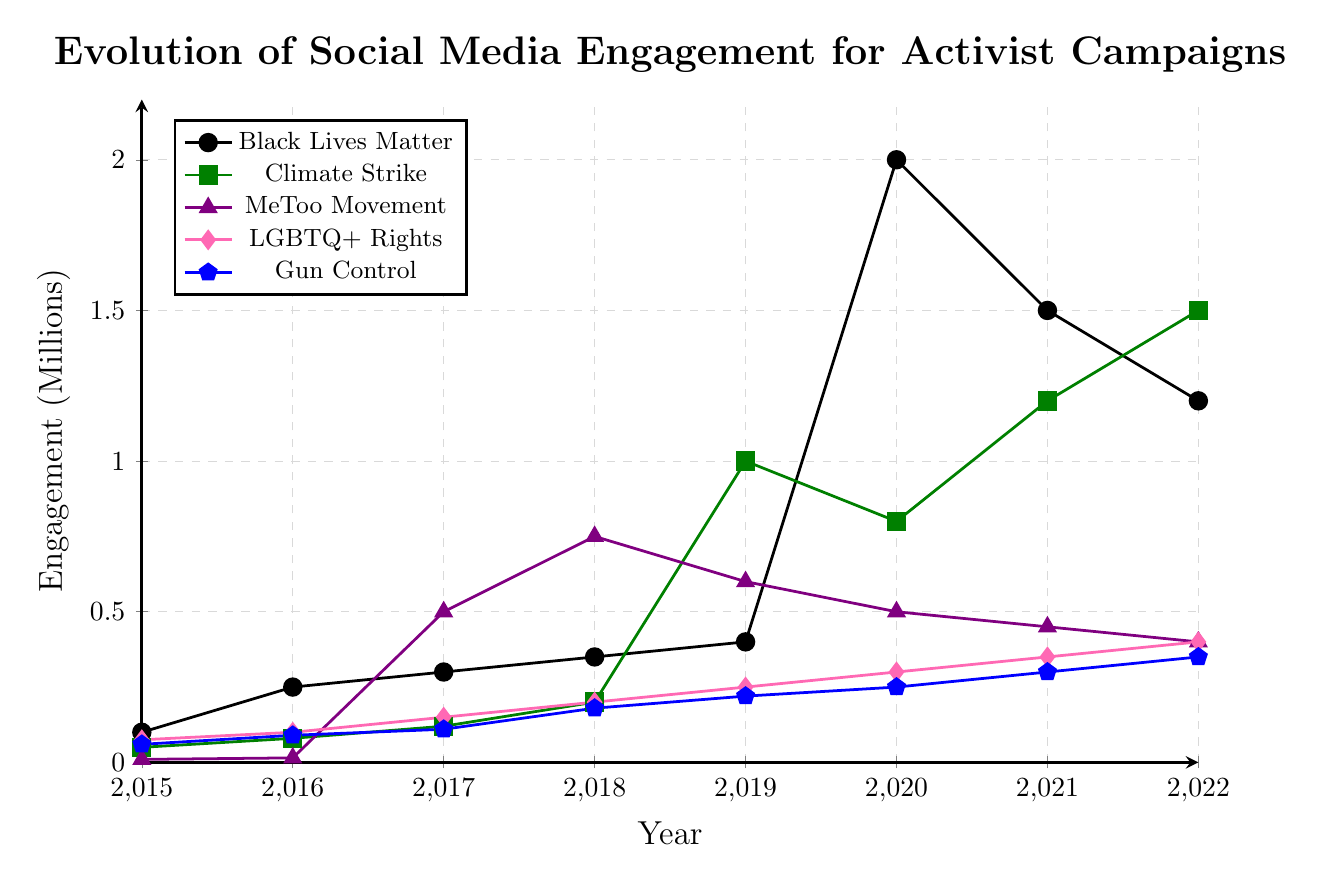What was the highest engagement for the Black Lives Matter campaign, and in what year did it occur? The highest engagement for the Black Lives Matter campaign can be identified by looking at the peak value on the chart. This value occurs in the year 2020.
Answer: 2020, 2 million Which campaign had the lowest engagement in 2015 and what was the value? To find the campaign with the lowest engagement in 2015, look at the starting values for all campaigns in 2015. The MeToo Movement had the lowest engagement at 0.01 million (10,000).
Answer: MeToo Movement, 0.01 million By how much did the engagement for Climate Strike increase from 2017 to 2018? Check the values for Climate Strike in the years 2017 and 2018. In 2017, it was 0.12 million, and in 2018, it was 0.2 million. The increase is 0.2 - 0.12 = 0.08 million.
Answer: 0.08 million Compare the engagement trends of the Gun Control campaign and the LGBTQ+ Rights campaign in 2022. Which had higher engagement and by how much? To compare, check the engagement levels for both campaigns in 2022. Gun Control had 0.35 million, and LGBTQ+ Rights had 0.4 million. LGBTQ+ Rights had higher engagement by 0.4 - 0.35 = 0.05 million.
Answer: LGBTQ+ Rights, 0.05 million What is the average engagement for the MeToo Movement campaign from 2017 to 2022? To find the average engagement, sum the values of the MeToo Movement from 2017 to 2022 and divide by the number of years. (0.5 + 0.75 + 0.6 + 0.5 + 0.45 + 0.4) / 6 = 3.2 / 6 = 0.533 million.
Answer: 0.533 million In 2019, which campaign witnessed the highest engagement, and what was its engagement level? Check the engagement values for all campaigns in the year 2019. Climate Strike had the highest engagement at 1 million.
Answer: Climate Strike, 1 million Which year shows a drop in engagement for the Gun Control campaign compared to the previous year, and what is the difference? Look for the year-over-year engagement values of the Gun Control campaign. From 2018 to 2019, there is a slight drop, but it's an increase when compared to previous years. There's no actual drop.
Answer: None How many campaigns had an engagement of at least 1 million in any given year? Look through each year's data to find campaigns that reached at least 1 million engagement. Black Lives Matter reached 1 million in 2020 and 2021. Climate Strike reached 1 million in 2019, 2021, and 2022. So, two campaigns meet this criterion.
Answer: Two campaigns If you sum the highest engagement figures for all campaigns over the years, what is the total? Identify the highest engagement figure for each campaign and sum them up. Black Lives Matter: 2 million, Climate Strike: 1.5 million, MeToo Movement: 0.75 million, LGBTQ+ Rights: 0.4 million, Gun Control: 0.35 million. Total = 2 + 1.5 + 0.75 + 0.4 + 0.35 = 5 million.
Answer: 5 million 